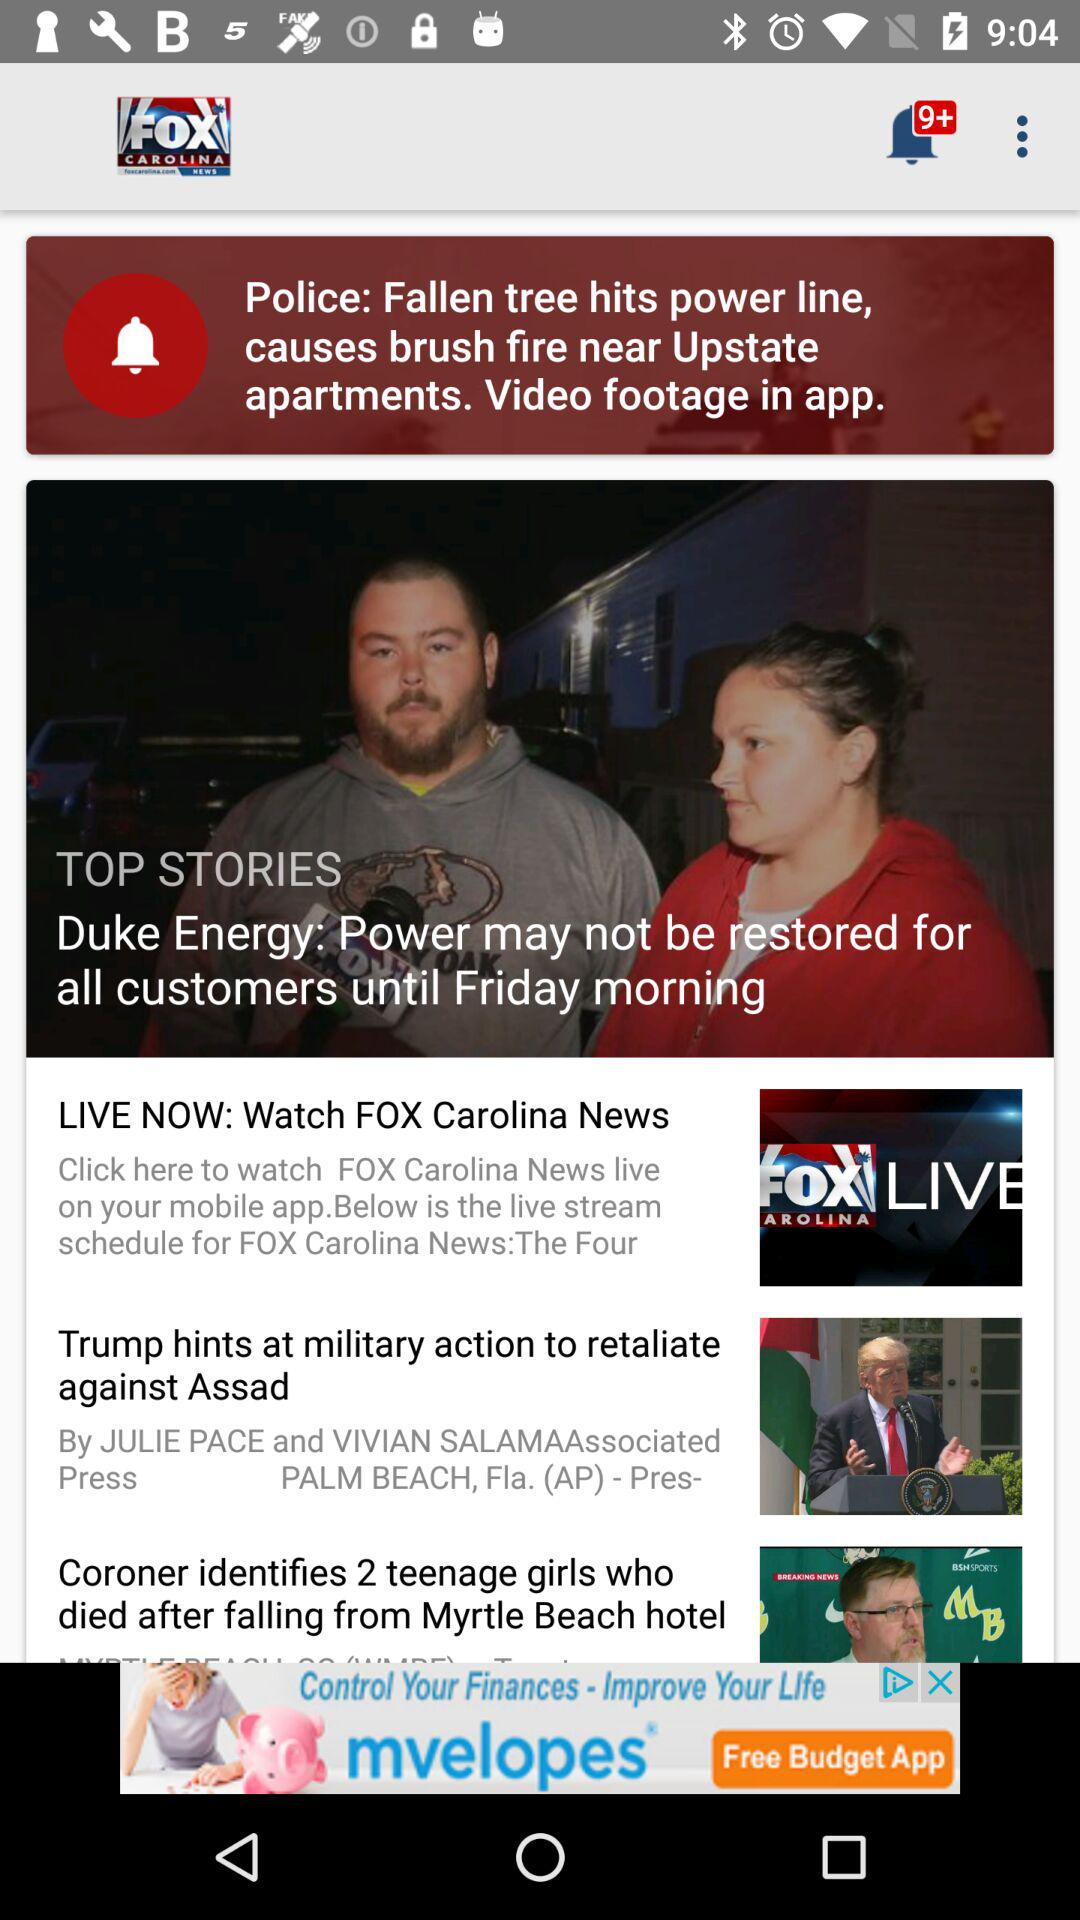What is the title of the story? The titles of the stories are "Police: Fallen tree hits power line, causes brush fire near Upstate apartments. Video footage in app.", "Duke Energy: Power may not be restored for all customers until Friday morning", "Trump hints at military action to retaliate against Assad" and "Coroner identifies 2 teenage girls who died after falling from Myrtle Beach hotel". 